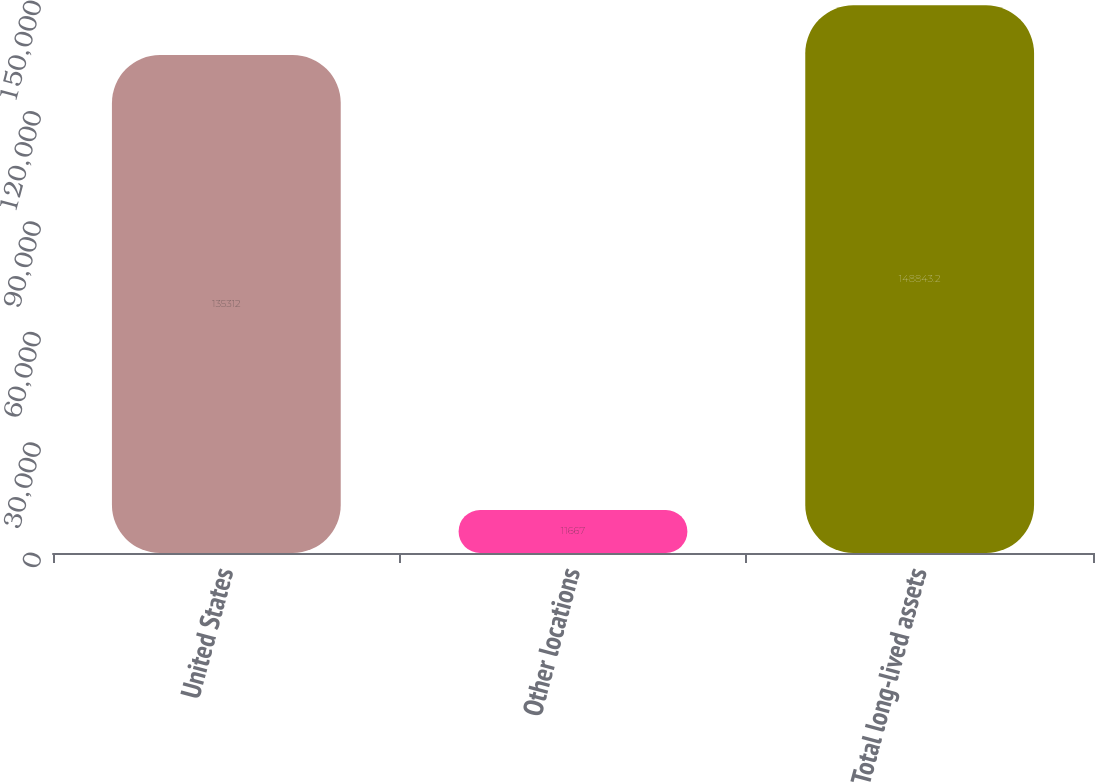Convert chart to OTSL. <chart><loc_0><loc_0><loc_500><loc_500><bar_chart><fcel>United States<fcel>Other locations<fcel>Total long-lived assets<nl><fcel>135312<fcel>11667<fcel>148843<nl></chart> 